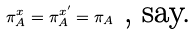<formula> <loc_0><loc_0><loc_500><loc_500>\pi _ { A } ^ { x } = \pi _ { A } ^ { x ^ { \prime } } = \pi _ { A } \text {\ , say.}</formula> 